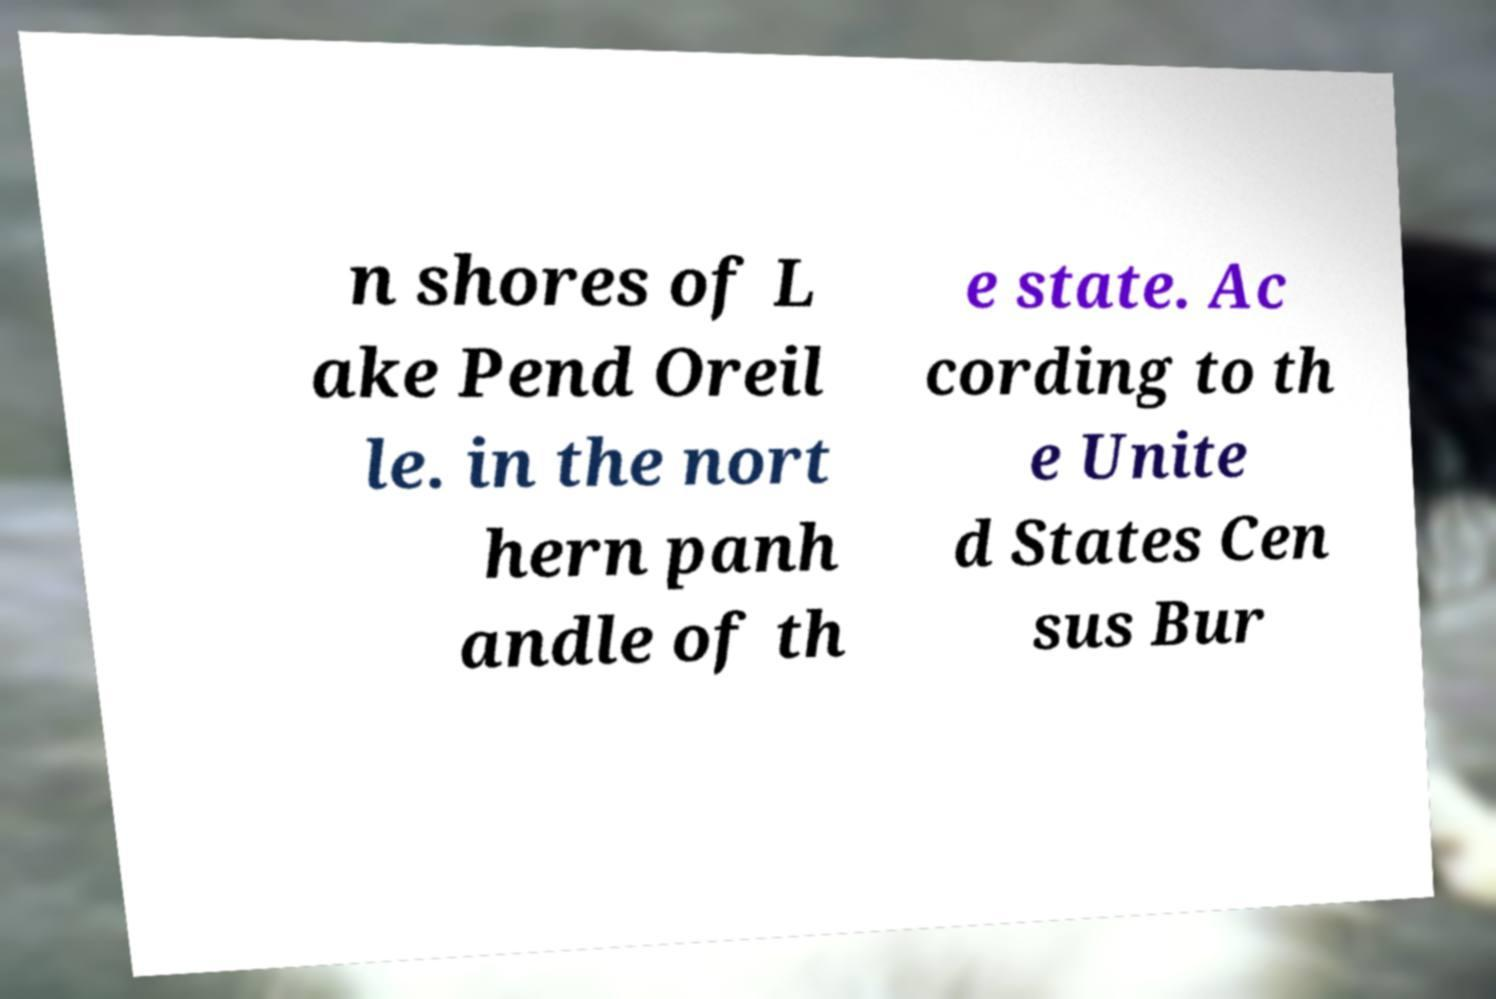I need the written content from this picture converted into text. Can you do that? n shores of L ake Pend Oreil le. in the nort hern panh andle of th e state. Ac cording to th e Unite d States Cen sus Bur 